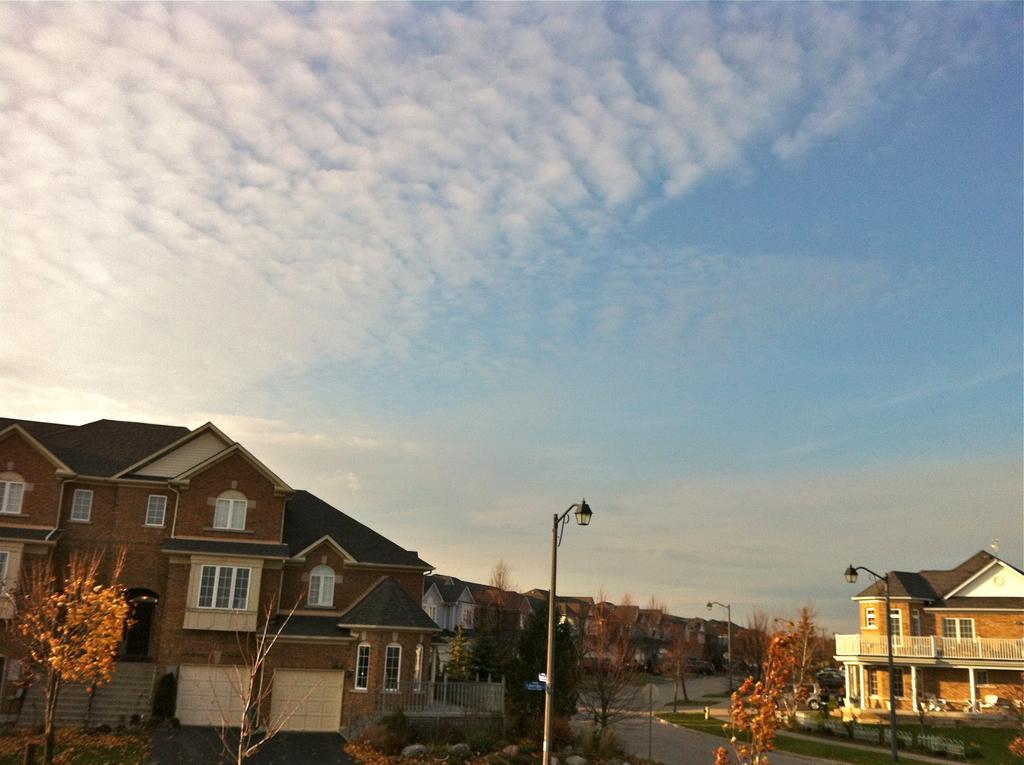In one or two sentences, can you explain what this image depicts? In this image we can see houses, poles, road, trees. At the top of the image there is sky. 